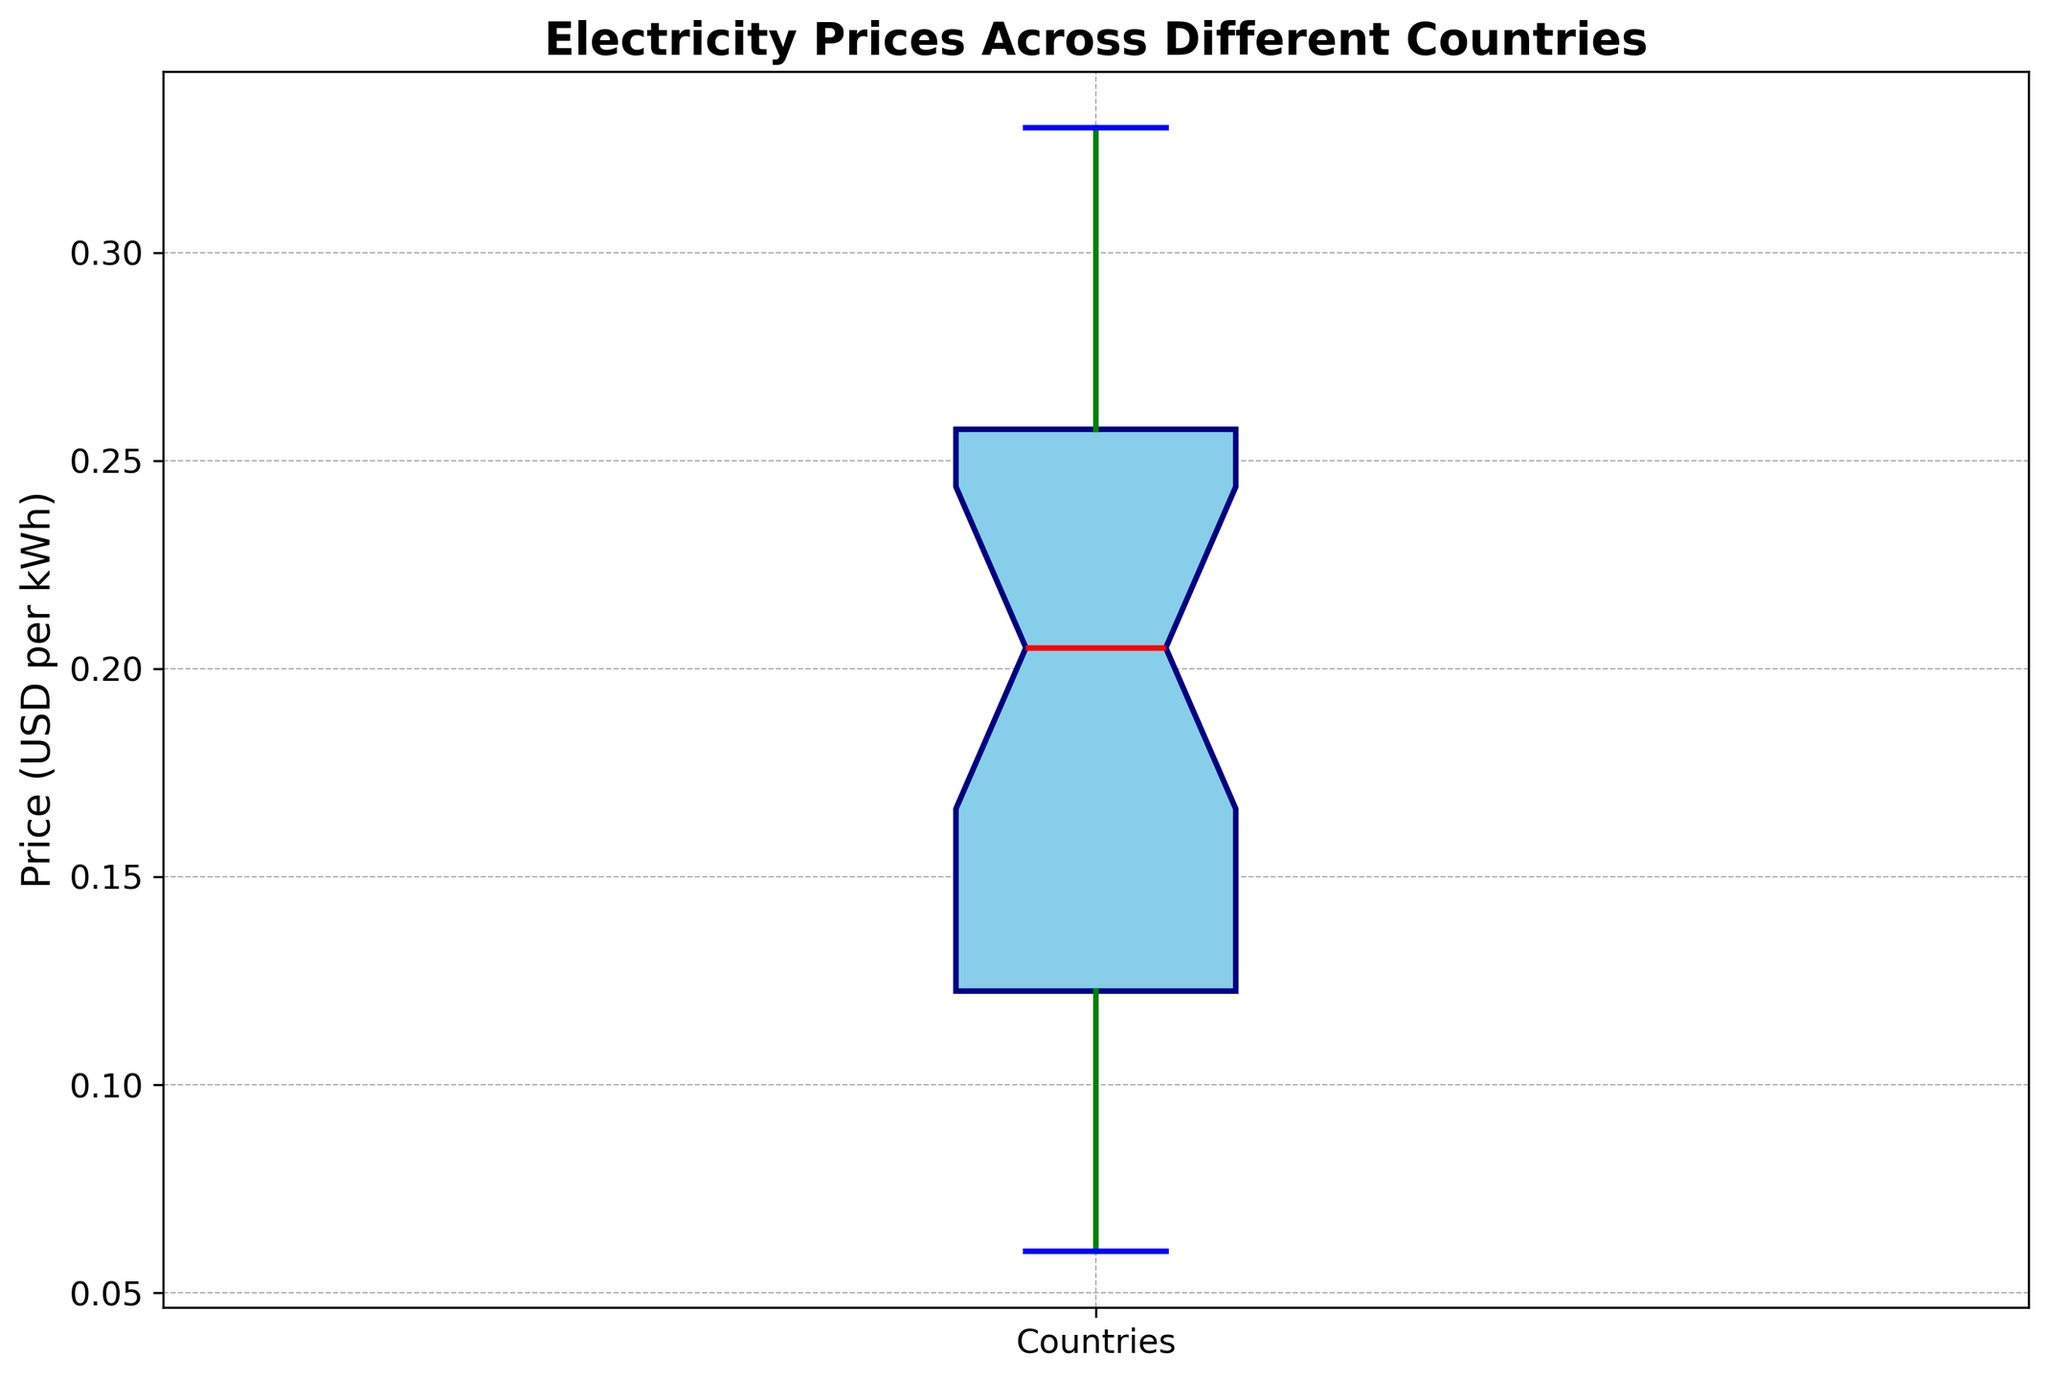What is the median electricity price across different countries? The box plot's median is represented by the red line inside the box. From the plot, the median price can be visually identified as approximately halfway through the box.
Answer: $0.19 How does the upper quartile (75th percentile) compare to the lower quartile (25th percentile) in the box plot? The upper quartile is represented by the top edge of the box, while the lower quartile is the bottom edge. Visually, the distance between these edges provides a sense of spread.
Answer: The upper quartile is higher than the lower quartile Which is more variable among the countries: electricity prices above or below the median? By comparing the lengths of the whiskers above and below the box, variability can be assessed. The longer whisker indicates more variability.
Answer: Below the median How does the highest electricity price compare to the lowest electricity price? The highest price is shown by the upper whisker’s endpoint, and the lowest price by the lower whisker’s endpoint. Visually, the difference between these points shows the range of prices.
Answer: The highest price is significantly greater Is the median electricity price closer to the lower quartile or the upper quartile? The median line can be observed in relation to the box edges. If it's closer to the bottom of the box, it’s nearer the lower quartile, and vice versa.
Answer: Closer to the lower quartile Which countries are outliers based on electricity prices? Outliers are typically represented as individual dots outside the whiskers. These countries have electricity prices significantly different from the rest. Identifying any dots visually will reveal outlier countries.
Answer: None 